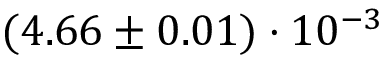Convert formula to latex. <formula><loc_0><loc_0><loc_500><loc_500>( 4 . 6 6 \pm 0 . 0 1 ) \cdot 1 0 ^ { - 3 }</formula> 